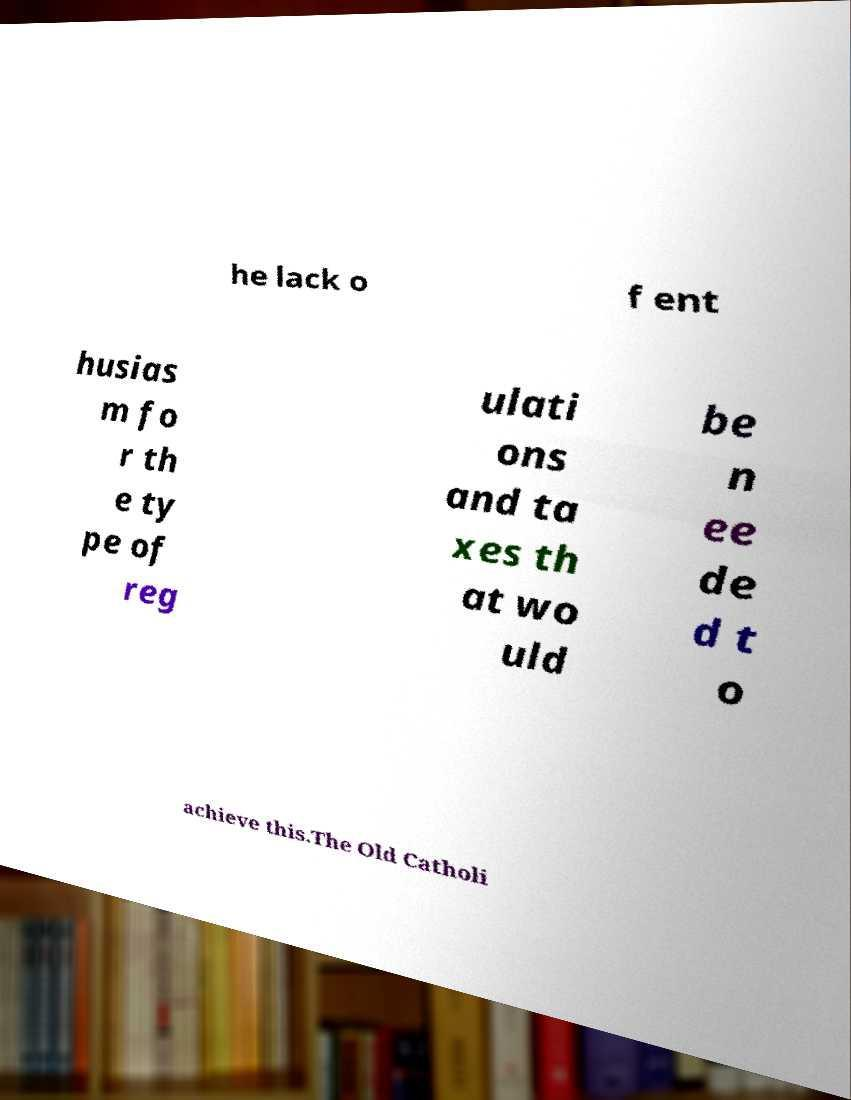For documentation purposes, I need the text within this image transcribed. Could you provide that? he lack o f ent husias m fo r th e ty pe of reg ulati ons and ta xes th at wo uld be n ee de d t o achieve this.The Old Catholi 